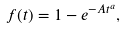Convert formula to latex. <formula><loc_0><loc_0><loc_500><loc_500>f ( t ) = 1 - e ^ { - A t ^ { a } } ,</formula> 